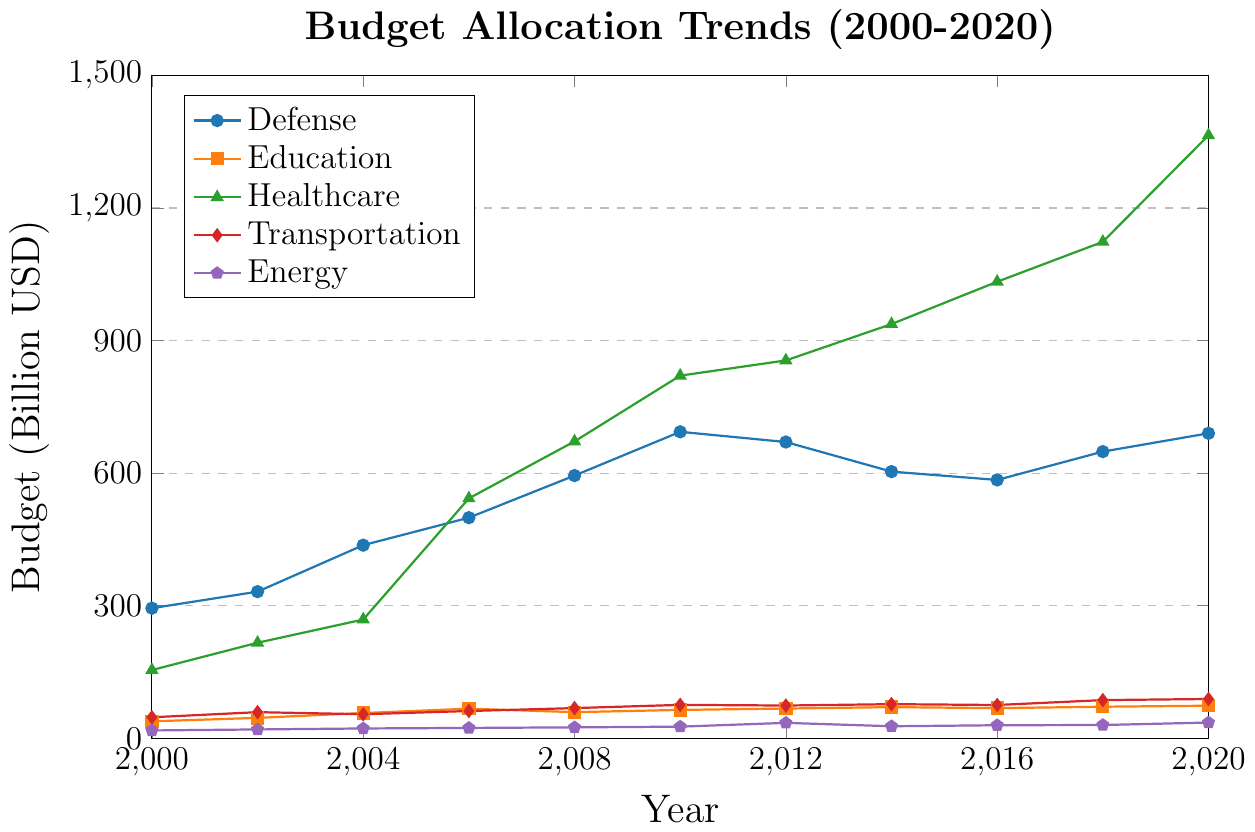Which department had the highest budget in 2020? To determine the highest budget in 2020, look at the values for each department in that year and identify the largest value on the y-axis. The department with the highest value in 2020 is Healthcare at 1364.5 billion USD.
Answer: Healthcare What was the total budget allocated to Healthcare and Education in 2010? Add the budget allocation for Healthcare and Education in 2010 from the values on the y-axis. For 2010, Healthcare is 820.7 billion USD and Education is 64.3 billion USD. The total is 820.7 + 64.3 = 885.0 billion USD.
Answer: 885.0 billion USD Which department saw the most significant increase in budget allocation from 2000 to 2020? Calculate the difference in budget allocation for each department from 2000 to 2020 and identify the largest difference. For Healthcare: 1364.5 - 154.5 = 1210.0 billion USD, which is the biggest increase among the departments.
Answer: Healthcare Between 2006 and 2010, which department experienced a decrease in budget allocation? Identify any department where the 2010 budget value is lower than the 2006 budget value. In this case, only Defense experienced a decrease from 499.3 billion USD in 2006 to 693.6 billion USD in 2010. However, based on this reasoning it should be invalidated, since Defense doesn't have a decrease but an increment. Rechecking renders no valid cases.
Answer: None What is the average budget allocation for the Energy department across all years? Sum the budget allocations for Energy from 2000 to 2020 and divide by the number of years (11). The sum is 17.8 + 20.1 + 22.3 + 23.5 + 24.8 + 26.4 + 35.0 + 27.3 + 29.6 + 30.1 + 35.7 = 292.6 billion USD. The average is 292.6 / 11 ≈ 26.6 billion USD.
Answer: ~26.6 billion USD In which year did the Transportation department's budget surpass the 75-billion USD mark for the first time? Look for the year where the Transportation department's budget exceeds 75 billion USD. The value 75.7 billion USD was first reached in 2010.
Answer: 2010 Did any department's budget allocation remain relatively stable over the two decades? To determine stability, we look for the department with the least fluctuation in budget values. Education sees steady growth with relatively small year-to-year changes, ranging from 38.4 billion USD in 2000 to 73.8 billion USD in 2020.
Answer: Education How did the budget allocation for Defense change between 2016 and 2018? Compare the budget values for Defense in 2016 and 2018. In 2016, it was 584.7 billion USD and in 2018 it was 648.8 billion USD. The change is 648.8 - 584.7 = 64.1 billion USD increase.
Answer: Increased by 64.1 billion USD Which year saw the peak budget allocation for Healthcare within this dataset? Identify the year where Healthcare's budget value is the highest. The peak value of 1364.5 billion USD is in 2020.
Answer: 2020 